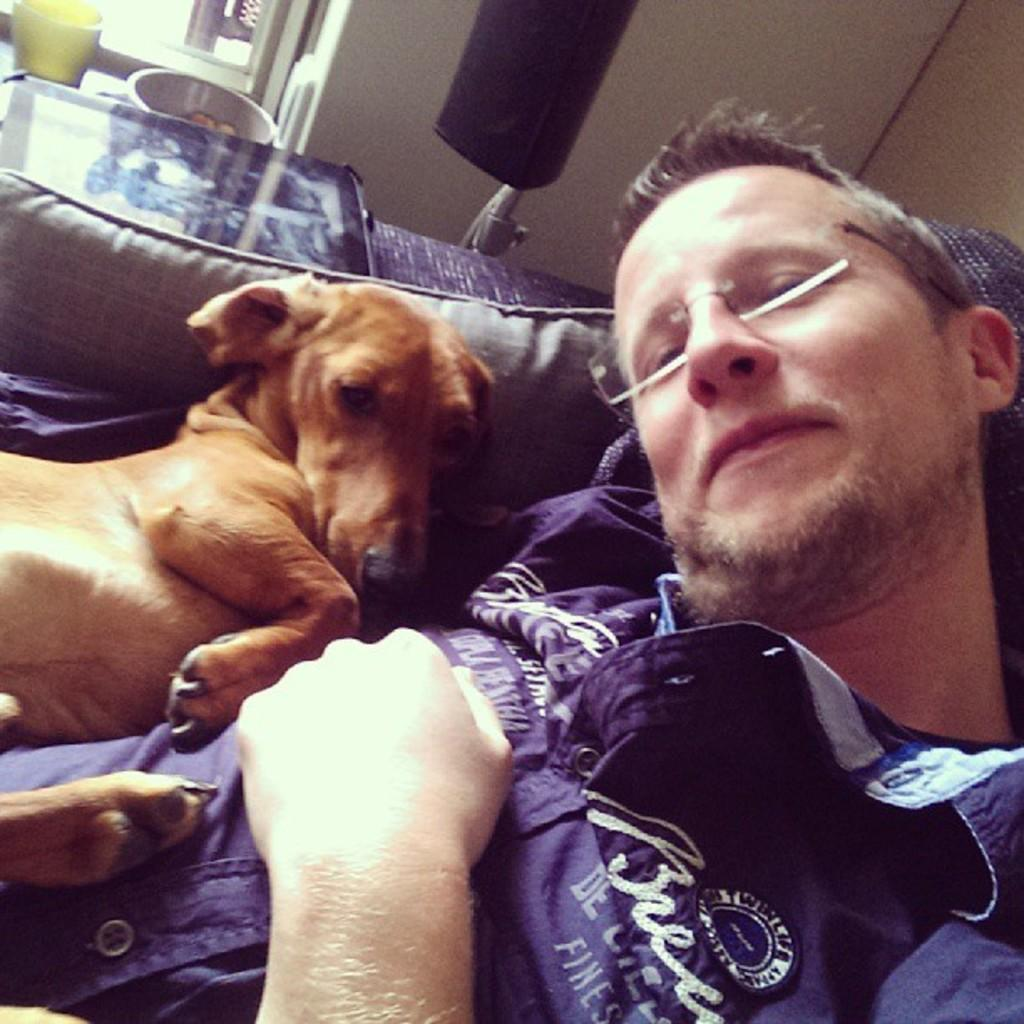Who is present in the image? There is a man and a dog in the image. What are they doing in the image? Both the man and the dog are laying on a couch. What objects can be seen near the man and the dog? There is an object that resembles a tablet and a black color object that resembles a speaker in the image. What is visible outside the room in the image? There is a window visible in the image. How many arms can be seen on the man in the image? There is no visible arm on the man in the image, as he is laying down with his back against the couch. What type of bike is visible in the image? There is no bike present in the image. 